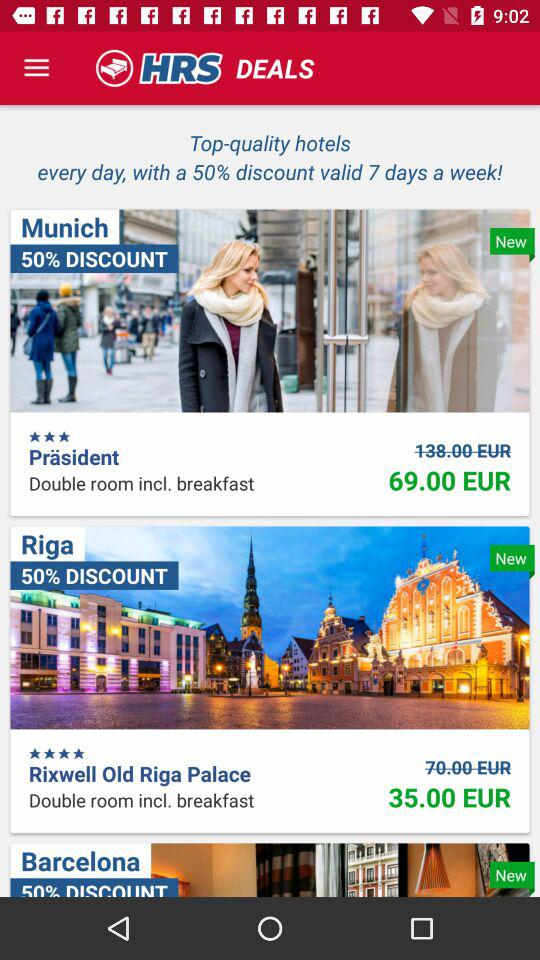What is the discounted rent for a double room in the "Präsident" hotel? The discounted rent for a double room in the "Präsident" hotel is 69 euros. 